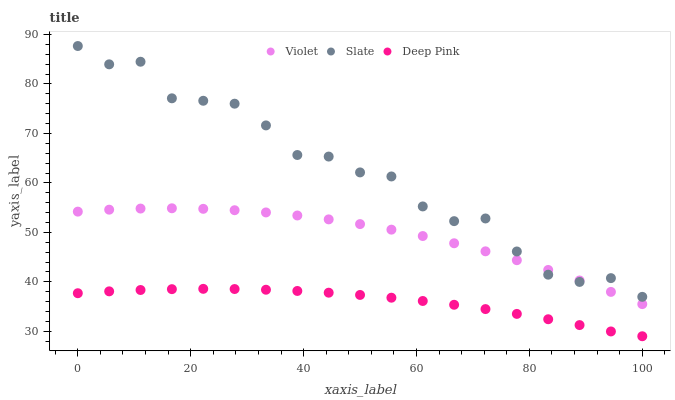Does Deep Pink have the minimum area under the curve?
Answer yes or no. Yes. Does Slate have the maximum area under the curve?
Answer yes or no. Yes. Does Violet have the minimum area under the curve?
Answer yes or no. No. Does Violet have the maximum area under the curve?
Answer yes or no. No. Is Deep Pink the smoothest?
Answer yes or no. Yes. Is Slate the roughest?
Answer yes or no. Yes. Is Violet the smoothest?
Answer yes or no. No. Is Violet the roughest?
Answer yes or no. No. Does Deep Pink have the lowest value?
Answer yes or no. Yes. Does Violet have the lowest value?
Answer yes or no. No. Does Slate have the highest value?
Answer yes or no. Yes. Does Violet have the highest value?
Answer yes or no. No. Is Deep Pink less than Violet?
Answer yes or no. Yes. Is Violet greater than Deep Pink?
Answer yes or no. Yes. Does Violet intersect Slate?
Answer yes or no. Yes. Is Violet less than Slate?
Answer yes or no. No. Is Violet greater than Slate?
Answer yes or no. No. Does Deep Pink intersect Violet?
Answer yes or no. No. 